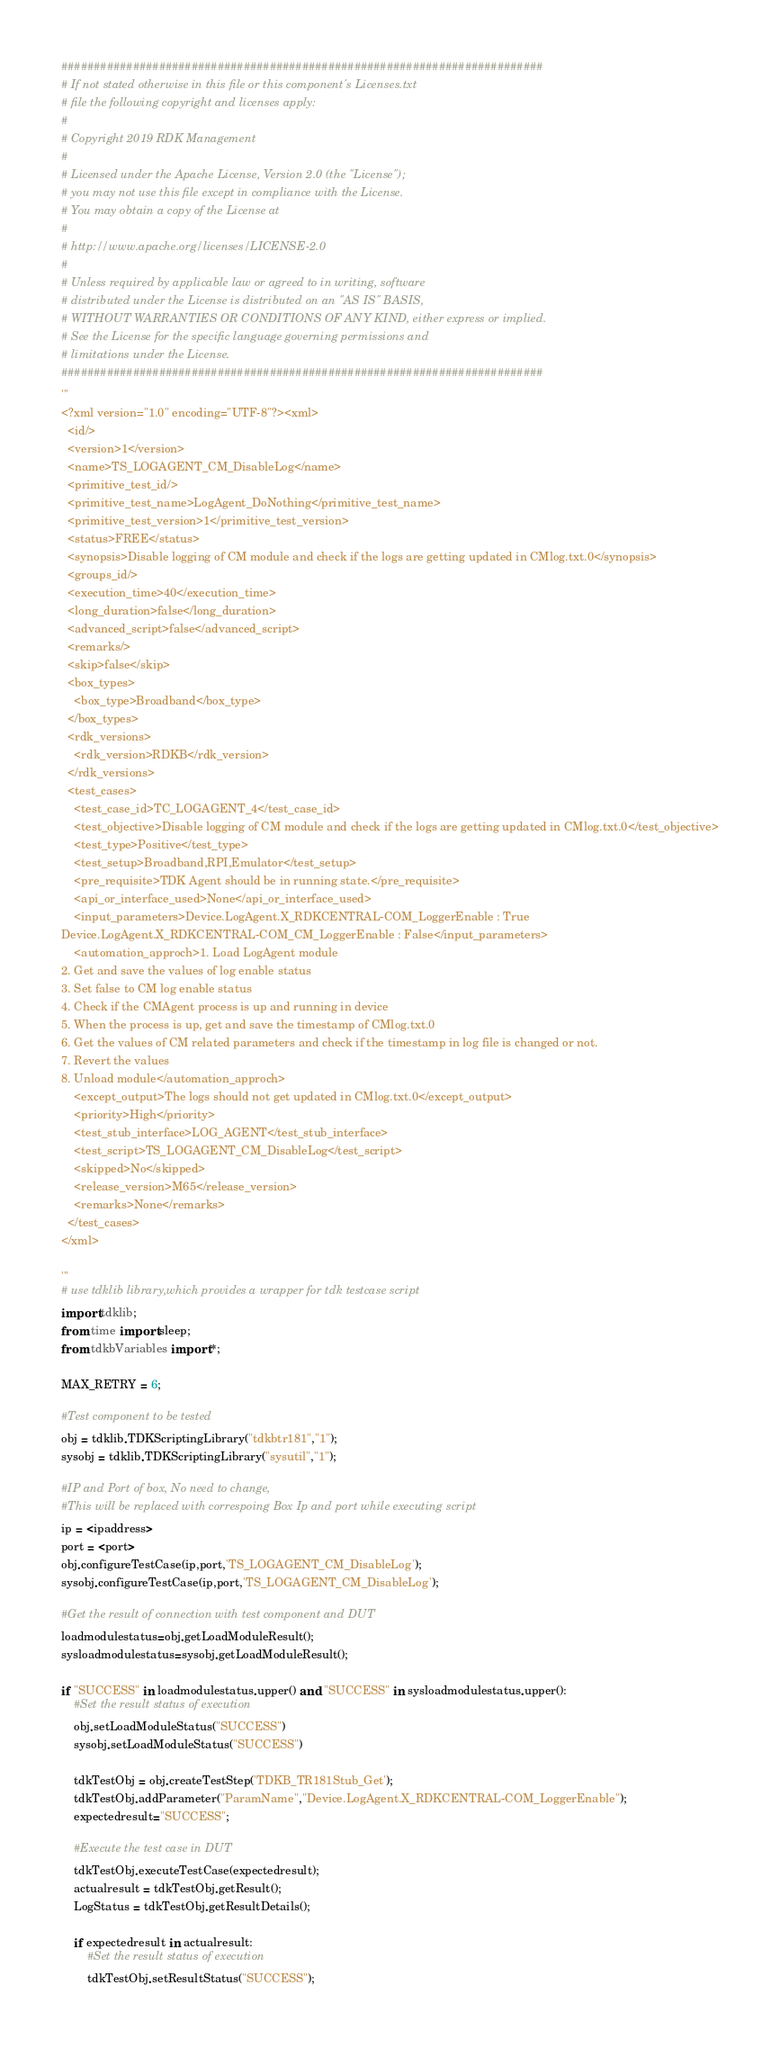Convert code to text. <code><loc_0><loc_0><loc_500><loc_500><_Python_>##########################################################################
# If not stated otherwise in this file or this component's Licenses.txt
# file the following copyright and licenses apply:
#
# Copyright 2019 RDK Management
#
# Licensed under the Apache License, Version 2.0 (the "License");
# you may not use this file except in compliance with the License.
# You may obtain a copy of the License at
#
# http://www.apache.org/licenses/LICENSE-2.0
#
# Unless required by applicable law or agreed to in writing, software
# distributed under the License is distributed on an "AS IS" BASIS,
# WITHOUT WARRANTIES OR CONDITIONS OF ANY KIND, either express or implied.
# See the License for the specific language governing permissions and
# limitations under the License.
##########################################################################
'''
<?xml version="1.0" encoding="UTF-8"?><xml>
  <id/>
  <version>1</version>
  <name>TS_LOGAGENT_CM_DisableLog</name>
  <primitive_test_id/>
  <primitive_test_name>LogAgent_DoNothing</primitive_test_name>
  <primitive_test_version>1</primitive_test_version>
  <status>FREE</status>
  <synopsis>Disable logging of CM module and check if the logs are getting updated in CMlog.txt.0</synopsis>
  <groups_id/>
  <execution_time>40</execution_time>
  <long_duration>false</long_duration>
  <advanced_script>false</advanced_script>
  <remarks/>
  <skip>false</skip>
  <box_types>
    <box_type>Broadband</box_type>
  </box_types>
  <rdk_versions>
    <rdk_version>RDKB</rdk_version>
  </rdk_versions>
  <test_cases>
    <test_case_id>TC_LOGAGENT_4</test_case_id>
    <test_objective>Disable logging of CM module and check if the logs are getting updated in CMlog.txt.0</test_objective>
    <test_type>Positive</test_type>
    <test_setup>Broadband,RPI,Emulator</test_setup>
    <pre_requisite>TDK Agent should be in running state.</pre_requisite>
    <api_or_interface_used>None</api_or_interface_used>
    <input_parameters>Device.LogAgent.X_RDKCENTRAL-COM_LoggerEnable : True
Device.LogAgent.X_RDKCENTRAL-COM_CM_LoggerEnable : False</input_parameters>
    <automation_approch>1. Load LogAgent module
2. Get and save the values of log enable status
3. Set false to CM log enable status
4. Check if the CMAgent process is up and running in device
5. When the process is up, get and save the timestamp of CMlog.txt.0
6. Get the values of CM related parameters and check if the timestamp in log file is changed or not.
7. Revert the values
8. Unload module</automation_approch>
    <except_output>The logs should not get updated in CMlog.txt.0</except_output>
    <priority>High</priority>
    <test_stub_interface>LOG_AGENT</test_stub_interface>
    <test_script>TS_LOGAGENT_CM_DisableLog</test_script>
    <skipped>No</skipped>
    <release_version>M65</release_version>
    <remarks>None</remarks>
  </test_cases>
</xml>

'''
# use tdklib library,which provides a wrapper for tdk testcase script 
import tdklib; 
from time import sleep;
from tdkbVariables import *;

MAX_RETRY = 6;

#Test component to be tested
obj = tdklib.TDKScriptingLibrary("tdkbtr181","1");
sysobj = tdklib.TDKScriptingLibrary("sysutil","1");

#IP and Port of box, No need to change,
#This will be replaced with correspoing Box Ip and port while executing script
ip = <ipaddress>
port = <port>
obj.configureTestCase(ip,port,'TS_LOGAGENT_CM_DisableLog');
sysobj.configureTestCase(ip,port,'TS_LOGAGENT_CM_DisableLog');

#Get the result of connection with test component and DUT
loadmodulestatus=obj.getLoadModuleResult();
sysloadmodulestatus=sysobj.getLoadModuleResult();

if "SUCCESS" in loadmodulestatus.upper() and "SUCCESS" in sysloadmodulestatus.upper():
    #Set the result status of execution
    obj.setLoadModuleStatus("SUCCESS")
    sysobj.setLoadModuleStatus("SUCCESS")

    tdkTestObj = obj.createTestStep('TDKB_TR181Stub_Get');
    tdkTestObj.addParameter("ParamName","Device.LogAgent.X_RDKCENTRAL-COM_LoggerEnable");
    expectedresult="SUCCESS";

    #Execute the test case in DUT
    tdkTestObj.executeTestCase(expectedresult);
    actualresult = tdkTestObj.getResult();
    LogStatus = tdkTestObj.getResultDetails();

    if expectedresult in actualresult:
        #Set the result status of execution
        tdkTestObj.setResultStatus("SUCCESS");</code> 